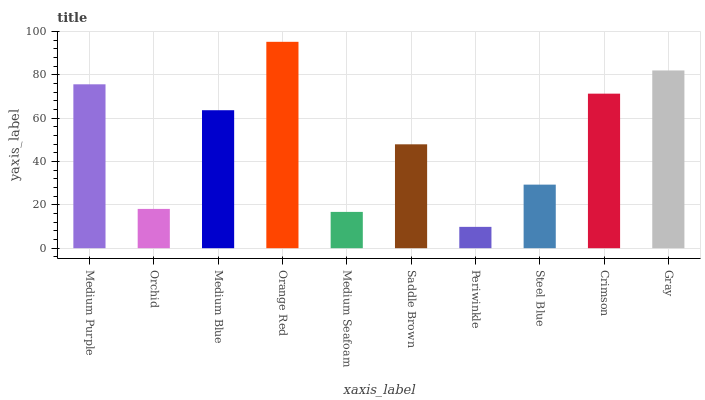Is Periwinkle the minimum?
Answer yes or no. Yes. Is Orange Red the maximum?
Answer yes or no. Yes. Is Orchid the minimum?
Answer yes or no. No. Is Orchid the maximum?
Answer yes or no. No. Is Medium Purple greater than Orchid?
Answer yes or no. Yes. Is Orchid less than Medium Purple?
Answer yes or no. Yes. Is Orchid greater than Medium Purple?
Answer yes or no. No. Is Medium Purple less than Orchid?
Answer yes or no. No. Is Medium Blue the high median?
Answer yes or no. Yes. Is Saddle Brown the low median?
Answer yes or no. Yes. Is Medium Purple the high median?
Answer yes or no. No. Is Orchid the low median?
Answer yes or no. No. 